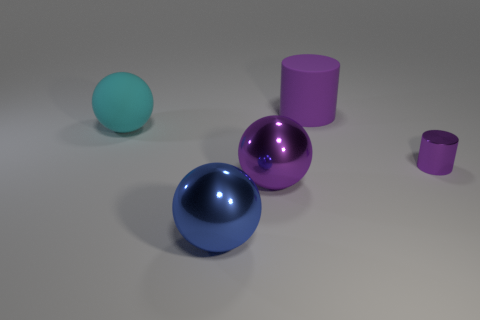Subtract all big rubber spheres. How many spheres are left? 2 Add 4 big gray metal things. How many objects exist? 9 Subtract all spheres. How many objects are left? 2 Subtract 2 cylinders. How many cylinders are left? 0 Subtract all purple spheres. How many spheres are left? 2 Subtract all yellow cylinders. How many blue spheres are left? 1 Subtract all big yellow rubber cylinders. Subtract all tiny purple metal objects. How many objects are left? 4 Add 1 large purple metal balls. How many large purple metal balls are left? 2 Add 3 small blue rubber cylinders. How many small blue rubber cylinders exist? 3 Subtract 0 red spheres. How many objects are left? 5 